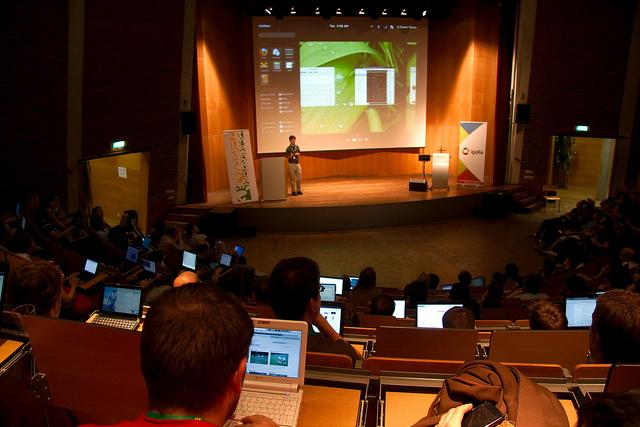What type of classroom could this be called? lecture hall 